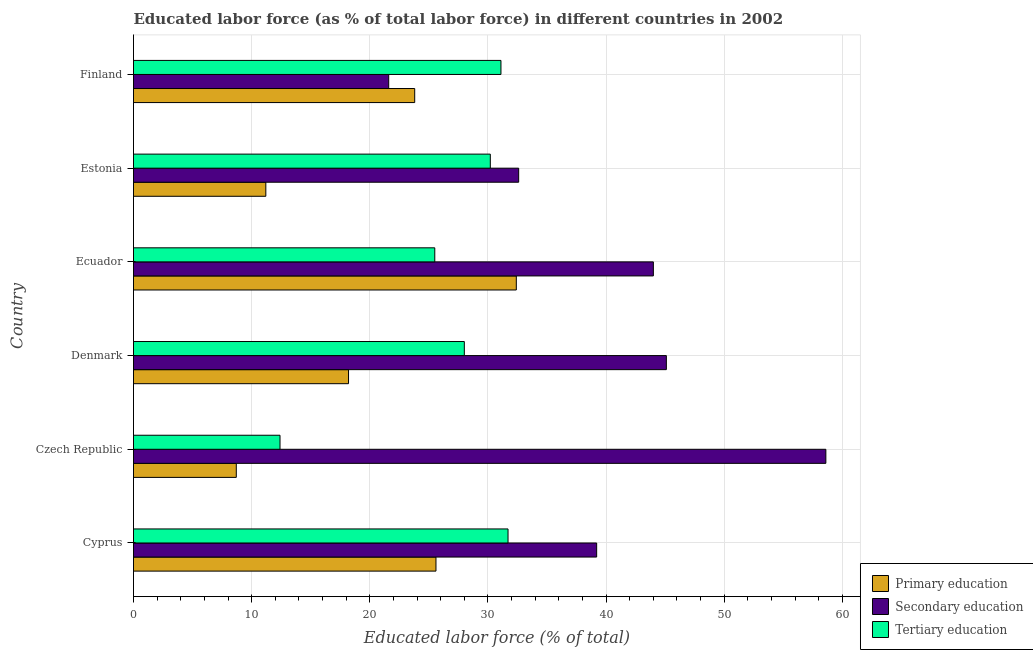How many bars are there on the 2nd tick from the top?
Ensure brevity in your answer.  3. What is the label of the 3rd group of bars from the top?
Make the answer very short. Ecuador. What is the percentage of labor force who received tertiary education in Cyprus?
Offer a very short reply. 31.7. Across all countries, what is the maximum percentage of labor force who received secondary education?
Your response must be concise. 58.6. Across all countries, what is the minimum percentage of labor force who received primary education?
Provide a short and direct response. 8.7. In which country was the percentage of labor force who received secondary education maximum?
Offer a terse response. Czech Republic. In which country was the percentage of labor force who received tertiary education minimum?
Provide a short and direct response. Czech Republic. What is the total percentage of labor force who received tertiary education in the graph?
Offer a very short reply. 158.9. What is the difference between the percentage of labor force who received tertiary education in Czech Republic and that in Estonia?
Your answer should be very brief. -17.8. What is the difference between the percentage of labor force who received primary education in Estonia and the percentage of labor force who received tertiary education in Denmark?
Offer a very short reply. -16.8. What is the average percentage of labor force who received primary education per country?
Your answer should be compact. 19.98. What is the difference between the percentage of labor force who received secondary education and percentage of labor force who received primary education in Finland?
Your answer should be compact. -2.2. In how many countries, is the percentage of labor force who received primary education greater than 8 %?
Offer a terse response. 6. What is the ratio of the percentage of labor force who received tertiary education in Czech Republic to that in Finland?
Provide a short and direct response. 0.4. Is the difference between the percentage of labor force who received primary education in Czech Republic and Denmark greater than the difference between the percentage of labor force who received tertiary education in Czech Republic and Denmark?
Keep it short and to the point. Yes. What is the difference between the highest and the second highest percentage of labor force who received secondary education?
Keep it short and to the point. 13.5. Is the sum of the percentage of labor force who received secondary education in Denmark and Estonia greater than the maximum percentage of labor force who received primary education across all countries?
Your response must be concise. Yes. What does the 1st bar from the bottom in Denmark represents?
Ensure brevity in your answer.  Primary education. How many bars are there?
Give a very brief answer. 18. What is the difference between two consecutive major ticks on the X-axis?
Your answer should be very brief. 10. Are the values on the major ticks of X-axis written in scientific E-notation?
Provide a short and direct response. No. Does the graph contain grids?
Ensure brevity in your answer.  Yes. How are the legend labels stacked?
Your response must be concise. Vertical. What is the title of the graph?
Ensure brevity in your answer.  Educated labor force (as % of total labor force) in different countries in 2002. What is the label or title of the X-axis?
Keep it short and to the point. Educated labor force (% of total). What is the Educated labor force (% of total) in Primary education in Cyprus?
Your answer should be compact. 25.6. What is the Educated labor force (% of total) of Secondary education in Cyprus?
Your answer should be very brief. 39.2. What is the Educated labor force (% of total) in Tertiary education in Cyprus?
Your response must be concise. 31.7. What is the Educated labor force (% of total) of Primary education in Czech Republic?
Your response must be concise. 8.7. What is the Educated labor force (% of total) of Secondary education in Czech Republic?
Make the answer very short. 58.6. What is the Educated labor force (% of total) in Tertiary education in Czech Republic?
Offer a very short reply. 12.4. What is the Educated labor force (% of total) of Primary education in Denmark?
Offer a terse response. 18.2. What is the Educated labor force (% of total) of Secondary education in Denmark?
Provide a succinct answer. 45.1. What is the Educated labor force (% of total) of Primary education in Ecuador?
Provide a short and direct response. 32.4. What is the Educated labor force (% of total) of Secondary education in Ecuador?
Give a very brief answer. 44. What is the Educated labor force (% of total) of Tertiary education in Ecuador?
Provide a short and direct response. 25.5. What is the Educated labor force (% of total) in Primary education in Estonia?
Ensure brevity in your answer.  11.2. What is the Educated labor force (% of total) of Secondary education in Estonia?
Keep it short and to the point. 32.6. What is the Educated labor force (% of total) in Tertiary education in Estonia?
Your answer should be compact. 30.2. What is the Educated labor force (% of total) in Primary education in Finland?
Provide a succinct answer. 23.8. What is the Educated labor force (% of total) of Secondary education in Finland?
Offer a very short reply. 21.6. What is the Educated labor force (% of total) of Tertiary education in Finland?
Give a very brief answer. 31.1. Across all countries, what is the maximum Educated labor force (% of total) in Primary education?
Your answer should be compact. 32.4. Across all countries, what is the maximum Educated labor force (% of total) in Secondary education?
Give a very brief answer. 58.6. Across all countries, what is the maximum Educated labor force (% of total) in Tertiary education?
Your answer should be compact. 31.7. Across all countries, what is the minimum Educated labor force (% of total) of Primary education?
Your answer should be very brief. 8.7. Across all countries, what is the minimum Educated labor force (% of total) of Secondary education?
Offer a terse response. 21.6. Across all countries, what is the minimum Educated labor force (% of total) of Tertiary education?
Ensure brevity in your answer.  12.4. What is the total Educated labor force (% of total) in Primary education in the graph?
Offer a very short reply. 119.9. What is the total Educated labor force (% of total) in Secondary education in the graph?
Your answer should be compact. 241.1. What is the total Educated labor force (% of total) of Tertiary education in the graph?
Your answer should be very brief. 158.9. What is the difference between the Educated labor force (% of total) of Secondary education in Cyprus and that in Czech Republic?
Keep it short and to the point. -19.4. What is the difference between the Educated labor force (% of total) in Tertiary education in Cyprus and that in Czech Republic?
Your response must be concise. 19.3. What is the difference between the Educated labor force (% of total) in Primary education in Cyprus and that in Denmark?
Keep it short and to the point. 7.4. What is the difference between the Educated labor force (% of total) in Secondary education in Cyprus and that in Denmark?
Offer a terse response. -5.9. What is the difference between the Educated labor force (% of total) of Tertiary education in Cyprus and that in Ecuador?
Your response must be concise. 6.2. What is the difference between the Educated labor force (% of total) in Primary education in Czech Republic and that in Denmark?
Offer a very short reply. -9.5. What is the difference between the Educated labor force (% of total) of Tertiary education in Czech Republic and that in Denmark?
Offer a terse response. -15.6. What is the difference between the Educated labor force (% of total) in Primary education in Czech Republic and that in Ecuador?
Your response must be concise. -23.7. What is the difference between the Educated labor force (% of total) in Tertiary education in Czech Republic and that in Ecuador?
Your answer should be very brief. -13.1. What is the difference between the Educated labor force (% of total) of Primary education in Czech Republic and that in Estonia?
Provide a short and direct response. -2.5. What is the difference between the Educated labor force (% of total) of Tertiary education in Czech Republic and that in Estonia?
Keep it short and to the point. -17.8. What is the difference between the Educated labor force (% of total) of Primary education in Czech Republic and that in Finland?
Offer a very short reply. -15.1. What is the difference between the Educated labor force (% of total) of Secondary education in Czech Republic and that in Finland?
Your answer should be very brief. 37. What is the difference between the Educated labor force (% of total) of Tertiary education in Czech Republic and that in Finland?
Make the answer very short. -18.7. What is the difference between the Educated labor force (% of total) of Primary education in Denmark and that in Ecuador?
Offer a terse response. -14.2. What is the difference between the Educated labor force (% of total) in Secondary education in Denmark and that in Ecuador?
Ensure brevity in your answer.  1.1. What is the difference between the Educated labor force (% of total) in Tertiary education in Denmark and that in Ecuador?
Keep it short and to the point. 2.5. What is the difference between the Educated labor force (% of total) of Primary education in Denmark and that in Estonia?
Keep it short and to the point. 7. What is the difference between the Educated labor force (% of total) in Secondary education in Denmark and that in Estonia?
Your response must be concise. 12.5. What is the difference between the Educated labor force (% of total) of Tertiary education in Denmark and that in Estonia?
Keep it short and to the point. -2.2. What is the difference between the Educated labor force (% of total) in Primary education in Denmark and that in Finland?
Offer a terse response. -5.6. What is the difference between the Educated labor force (% of total) of Secondary education in Denmark and that in Finland?
Your response must be concise. 23.5. What is the difference between the Educated labor force (% of total) in Primary education in Ecuador and that in Estonia?
Offer a very short reply. 21.2. What is the difference between the Educated labor force (% of total) in Secondary education in Ecuador and that in Estonia?
Your response must be concise. 11.4. What is the difference between the Educated labor force (% of total) of Tertiary education in Ecuador and that in Estonia?
Your answer should be compact. -4.7. What is the difference between the Educated labor force (% of total) of Primary education in Ecuador and that in Finland?
Your answer should be very brief. 8.6. What is the difference between the Educated labor force (% of total) in Secondary education in Ecuador and that in Finland?
Offer a terse response. 22.4. What is the difference between the Educated labor force (% of total) of Tertiary education in Ecuador and that in Finland?
Make the answer very short. -5.6. What is the difference between the Educated labor force (% of total) of Primary education in Estonia and that in Finland?
Your answer should be compact. -12.6. What is the difference between the Educated labor force (% of total) in Secondary education in Estonia and that in Finland?
Offer a very short reply. 11. What is the difference between the Educated labor force (% of total) of Tertiary education in Estonia and that in Finland?
Provide a succinct answer. -0.9. What is the difference between the Educated labor force (% of total) of Primary education in Cyprus and the Educated labor force (% of total) of Secondary education in Czech Republic?
Ensure brevity in your answer.  -33. What is the difference between the Educated labor force (% of total) in Primary education in Cyprus and the Educated labor force (% of total) in Tertiary education in Czech Republic?
Offer a very short reply. 13.2. What is the difference between the Educated labor force (% of total) in Secondary education in Cyprus and the Educated labor force (% of total) in Tertiary education in Czech Republic?
Keep it short and to the point. 26.8. What is the difference between the Educated labor force (% of total) of Primary education in Cyprus and the Educated labor force (% of total) of Secondary education in Denmark?
Make the answer very short. -19.5. What is the difference between the Educated labor force (% of total) in Secondary education in Cyprus and the Educated labor force (% of total) in Tertiary education in Denmark?
Provide a short and direct response. 11.2. What is the difference between the Educated labor force (% of total) in Primary education in Cyprus and the Educated labor force (% of total) in Secondary education in Ecuador?
Ensure brevity in your answer.  -18.4. What is the difference between the Educated labor force (% of total) in Primary education in Cyprus and the Educated labor force (% of total) in Tertiary education in Ecuador?
Provide a succinct answer. 0.1. What is the difference between the Educated labor force (% of total) in Secondary education in Cyprus and the Educated labor force (% of total) in Tertiary education in Ecuador?
Offer a very short reply. 13.7. What is the difference between the Educated labor force (% of total) of Primary education in Cyprus and the Educated labor force (% of total) of Secondary education in Estonia?
Offer a very short reply. -7. What is the difference between the Educated labor force (% of total) of Primary education in Cyprus and the Educated labor force (% of total) of Tertiary education in Estonia?
Keep it short and to the point. -4.6. What is the difference between the Educated labor force (% of total) in Secondary education in Cyprus and the Educated labor force (% of total) in Tertiary education in Estonia?
Offer a terse response. 9. What is the difference between the Educated labor force (% of total) in Primary education in Czech Republic and the Educated labor force (% of total) in Secondary education in Denmark?
Your answer should be very brief. -36.4. What is the difference between the Educated labor force (% of total) in Primary education in Czech Republic and the Educated labor force (% of total) in Tertiary education in Denmark?
Your answer should be very brief. -19.3. What is the difference between the Educated labor force (% of total) in Secondary education in Czech Republic and the Educated labor force (% of total) in Tertiary education in Denmark?
Your answer should be compact. 30.6. What is the difference between the Educated labor force (% of total) of Primary education in Czech Republic and the Educated labor force (% of total) of Secondary education in Ecuador?
Keep it short and to the point. -35.3. What is the difference between the Educated labor force (% of total) of Primary education in Czech Republic and the Educated labor force (% of total) of Tertiary education in Ecuador?
Provide a short and direct response. -16.8. What is the difference between the Educated labor force (% of total) in Secondary education in Czech Republic and the Educated labor force (% of total) in Tertiary education in Ecuador?
Ensure brevity in your answer.  33.1. What is the difference between the Educated labor force (% of total) in Primary education in Czech Republic and the Educated labor force (% of total) in Secondary education in Estonia?
Your answer should be very brief. -23.9. What is the difference between the Educated labor force (% of total) of Primary education in Czech Republic and the Educated labor force (% of total) of Tertiary education in Estonia?
Your answer should be compact. -21.5. What is the difference between the Educated labor force (% of total) in Secondary education in Czech Republic and the Educated labor force (% of total) in Tertiary education in Estonia?
Offer a very short reply. 28.4. What is the difference between the Educated labor force (% of total) in Primary education in Czech Republic and the Educated labor force (% of total) in Tertiary education in Finland?
Offer a very short reply. -22.4. What is the difference between the Educated labor force (% of total) of Secondary education in Czech Republic and the Educated labor force (% of total) of Tertiary education in Finland?
Offer a very short reply. 27.5. What is the difference between the Educated labor force (% of total) in Primary education in Denmark and the Educated labor force (% of total) in Secondary education in Ecuador?
Give a very brief answer. -25.8. What is the difference between the Educated labor force (% of total) of Secondary education in Denmark and the Educated labor force (% of total) of Tertiary education in Ecuador?
Offer a terse response. 19.6. What is the difference between the Educated labor force (% of total) in Primary education in Denmark and the Educated labor force (% of total) in Secondary education in Estonia?
Your answer should be very brief. -14.4. What is the difference between the Educated labor force (% of total) in Secondary education in Denmark and the Educated labor force (% of total) in Tertiary education in Estonia?
Ensure brevity in your answer.  14.9. What is the difference between the Educated labor force (% of total) in Primary education in Denmark and the Educated labor force (% of total) in Secondary education in Finland?
Keep it short and to the point. -3.4. What is the difference between the Educated labor force (% of total) of Primary education in Ecuador and the Educated labor force (% of total) of Secondary education in Finland?
Offer a very short reply. 10.8. What is the difference between the Educated labor force (% of total) in Primary education in Estonia and the Educated labor force (% of total) in Secondary education in Finland?
Give a very brief answer. -10.4. What is the difference between the Educated labor force (% of total) of Primary education in Estonia and the Educated labor force (% of total) of Tertiary education in Finland?
Offer a terse response. -19.9. What is the average Educated labor force (% of total) of Primary education per country?
Make the answer very short. 19.98. What is the average Educated labor force (% of total) in Secondary education per country?
Offer a very short reply. 40.18. What is the average Educated labor force (% of total) of Tertiary education per country?
Provide a short and direct response. 26.48. What is the difference between the Educated labor force (% of total) of Primary education and Educated labor force (% of total) of Tertiary education in Cyprus?
Your answer should be compact. -6.1. What is the difference between the Educated labor force (% of total) of Secondary education and Educated labor force (% of total) of Tertiary education in Cyprus?
Your answer should be very brief. 7.5. What is the difference between the Educated labor force (% of total) of Primary education and Educated labor force (% of total) of Secondary education in Czech Republic?
Your answer should be very brief. -49.9. What is the difference between the Educated labor force (% of total) in Primary education and Educated labor force (% of total) in Tertiary education in Czech Republic?
Your response must be concise. -3.7. What is the difference between the Educated labor force (% of total) of Secondary education and Educated labor force (% of total) of Tertiary education in Czech Republic?
Your answer should be very brief. 46.2. What is the difference between the Educated labor force (% of total) in Primary education and Educated labor force (% of total) in Secondary education in Denmark?
Provide a succinct answer. -26.9. What is the difference between the Educated labor force (% of total) of Secondary education and Educated labor force (% of total) of Tertiary education in Denmark?
Your response must be concise. 17.1. What is the difference between the Educated labor force (% of total) of Primary education and Educated labor force (% of total) of Secondary education in Ecuador?
Offer a terse response. -11.6. What is the difference between the Educated labor force (% of total) of Primary education and Educated labor force (% of total) of Tertiary education in Ecuador?
Offer a very short reply. 6.9. What is the difference between the Educated labor force (% of total) in Primary education and Educated labor force (% of total) in Secondary education in Estonia?
Provide a succinct answer. -21.4. What is the difference between the Educated labor force (% of total) of Secondary education and Educated labor force (% of total) of Tertiary education in Estonia?
Offer a very short reply. 2.4. What is the difference between the Educated labor force (% of total) in Primary education and Educated labor force (% of total) in Secondary education in Finland?
Your answer should be very brief. 2.2. What is the difference between the Educated labor force (% of total) in Secondary education and Educated labor force (% of total) in Tertiary education in Finland?
Give a very brief answer. -9.5. What is the ratio of the Educated labor force (% of total) of Primary education in Cyprus to that in Czech Republic?
Offer a terse response. 2.94. What is the ratio of the Educated labor force (% of total) of Secondary education in Cyprus to that in Czech Republic?
Provide a short and direct response. 0.67. What is the ratio of the Educated labor force (% of total) in Tertiary education in Cyprus to that in Czech Republic?
Your answer should be very brief. 2.56. What is the ratio of the Educated labor force (% of total) of Primary education in Cyprus to that in Denmark?
Your answer should be compact. 1.41. What is the ratio of the Educated labor force (% of total) in Secondary education in Cyprus to that in Denmark?
Offer a very short reply. 0.87. What is the ratio of the Educated labor force (% of total) of Tertiary education in Cyprus to that in Denmark?
Ensure brevity in your answer.  1.13. What is the ratio of the Educated labor force (% of total) in Primary education in Cyprus to that in Ecuador?
Ensure brevity in your answer.  0.79. What is the ratio of the Educated labor force (% of total) in Secondary education in Cyprus to that in Ecuador?
Your answer should be compact. 0.89. What is the ratio of the Educated labor force (% of total) in Tertiary education in Cyprus to that in Ecuador?
Give a very brief answer. 1.24. What is the ratio of the Educated labor force (% of total) of Primary education in Cyprus to that in Estonia?
Your answer should be very brief. 2.29. What is the ratio of the Educated labor force (% of total) of Secondary education in Cyprus to that in Estonia?
Provide a succinct answer. 1.2. What is the ratio of the Educated labor force (% of total) in Tertiary education in Cyprus to that in Estonia?
Your response must be concise. 1.05. What is the ratio of the Educated labor force (% of total) of Primary education in Cyprus to that in Finland?
Offer a terse response. 1.08. What is the ratio of the Educated labor force (% of total) in Secondary education in Cyprus to that in Finland?
Ensure brevity in your answer.  1.81. What is the ratio of the Educated labor force (% of total) in Tertiary education in Cyprus to that in Finland?
Offer a very short reply. 1.02. What is the ratio of the Educated labor force (% of total) of Primary education in Czech Republic to that in Denmark?
Your response must be concise. 0.48. What is the ratio of the Educated labor force (% of total) in Secondary education in Czech Republic to that in Denmark?
Provide a short and direct response. 1.3. What is the ratio of the Educated labor force (% of total) of Tertiary education in Czech Republic to that in Denmark?
Your response must be concise. 0.44. What is the ratio of the Educated labor force (% of total) in Primary education in Czech Republic to that in Ecuador?
Make the answer very short. 0.27. What is the ratio of the Educated labor force (% of total) of Secondary education in Czech Republic to that in Ecuador?
Your answer should be compact. 1.33. What is the ratio of the Educated labor force (% of total) in Tertiary education in Czech Republic to that in Ecuador?
Provide a short and direct response. 0.49. What is the ratio of the Educated labor force (% of total) in Primary education in Czech Republic to that in Estonia?
Provide a succinct answer. 0.78. What is the ratio of the Educated labor force (% of total) in Secondary education in Czech Republic to that in Estonia?
Ensure brevity in your answer.  1.8. What is the ratio of the Educated labor force (% of total) of Tertiary education in Czech Republic to that in Estonia?
Keep it short and to the point. 0.41. What is the ratio of the Educated labor force (% of total) of Primary education in Czech Republic to that in Finland?
Your answer should be very brief. 0.37. What is the ratio of the Educated labor force (% of total) of Secondary education in Czech Republic to that in Finland?
Offer a very short reply. 2.71. What is the ratio of the Educated labor force (% of total) in Tertiary education in Czech Republic to that in Finland?
Offer a very short reply. 0.4. What is the ratio of the Educated labor force (% of total) in Primary education in Denmark to that in Ecuador?
Your response must be concise. 0.56. What is the ratio of the Educated labor force (% of total) in Tertiary education in Denmark to that in Ecuador?
Your answer should be compact. 1.1. What is the ratio of the Educated labor force (% of total) in Primary education in Denmark to that in Estonia?
Give a very brief answer. 1.62. What is the ratio of the Educated labor force (% of total) in Secondary education in Denmark to that in Estonia?
Keep it short and to the point. 1.38. What is the ratio of the Educated labor force (% of total) of Tertiary education in Denmark to that in Estonia?
Offer a very short reply. 0.93. What is the ratio of the Educated labor force (% of total) of Primary education in Denmark to that in Finland?
Make the answer very short. 0.76. What is the ratio of the Educated labor force (% of total) in Secondary education in Denmark to that in Finland?
Offer a very short reply. 2.09. What is the ratio of the Educated labor force (% of total) in Tertiary education in Denmark to that in Finland?
Your response must be concise. 0.9. What is the ratio of the Educated labor force (% of total) in Primary education in Ecuador to that in Estonia?
Offer a terse response. 2.89. What is the ratio of the Educated labor force (% of total) of Secondary education in Ecuador to that in Estonia?
Your response must be concise. 1.35. What is the ratio of the Educated labor force (% of total) in Tertiary education in Ecuador to that in Estonia?
Give a very brief answer. 0.84. What is the ratio of the Educated labor force (% of total) of Primary education in Ecuador to that in Finland?
Provide a short and direct response. 1.36. What is the ratio of the Educated labor force (% of total) of Secondary education in Ecuador to that in Finland?
Offer a very short reply. 2.04. What is the ratio of the Educated labor force (% of total) of Tertiary education in Ecuador to that in Finland?
Give a very brief answer. 0.82. What is the ratio of the Educated labor force (% of total) in Primary education in Estonia to that in Finland?
Provide a succinct answer. 0.47. What is the ratio of the Educated labor force (% of total) of Secondary education in Estonia to that in Finland?
Provide a succinct answer. 1.51. What is the ratio of the Educated labor force (% of total) in Tertiary education in Estonia to that in Finland?
Provide a short and direct response. 0.97. What is the difference between the highest and the second highest Educated labor force (% of total) in Primary education?
Ensure brevity in your answer.  6.8. What is the difference between the highest and the second highest Educated labor force (% of total) in Tertiary education?
Your response must be concise. 0.6. What is the difference between the highest and the lowest Educated labor force (% of total) of Primary education?
Your response must be concise. 23.7. What is the difference between the highest and the lowest Educated labor force (% of total) of Tertiary education?
Keep it short and to the point. 19.3. 